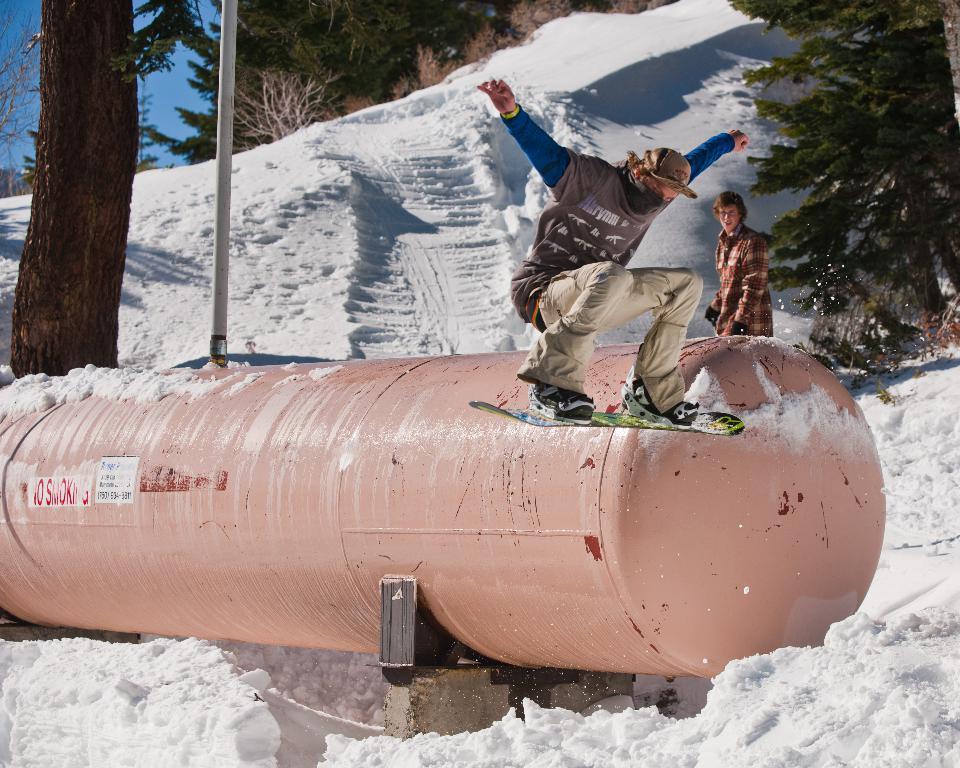Could you give a brief overview of what you see in this image? In this image there is a man flying in the air along with the skateboard. In the middle there is a big pipe on which there is a pole. On the left side there is a tree. In the background there is snow. On the right side there is another person standing beside the tree. At the bottom there is snow. 